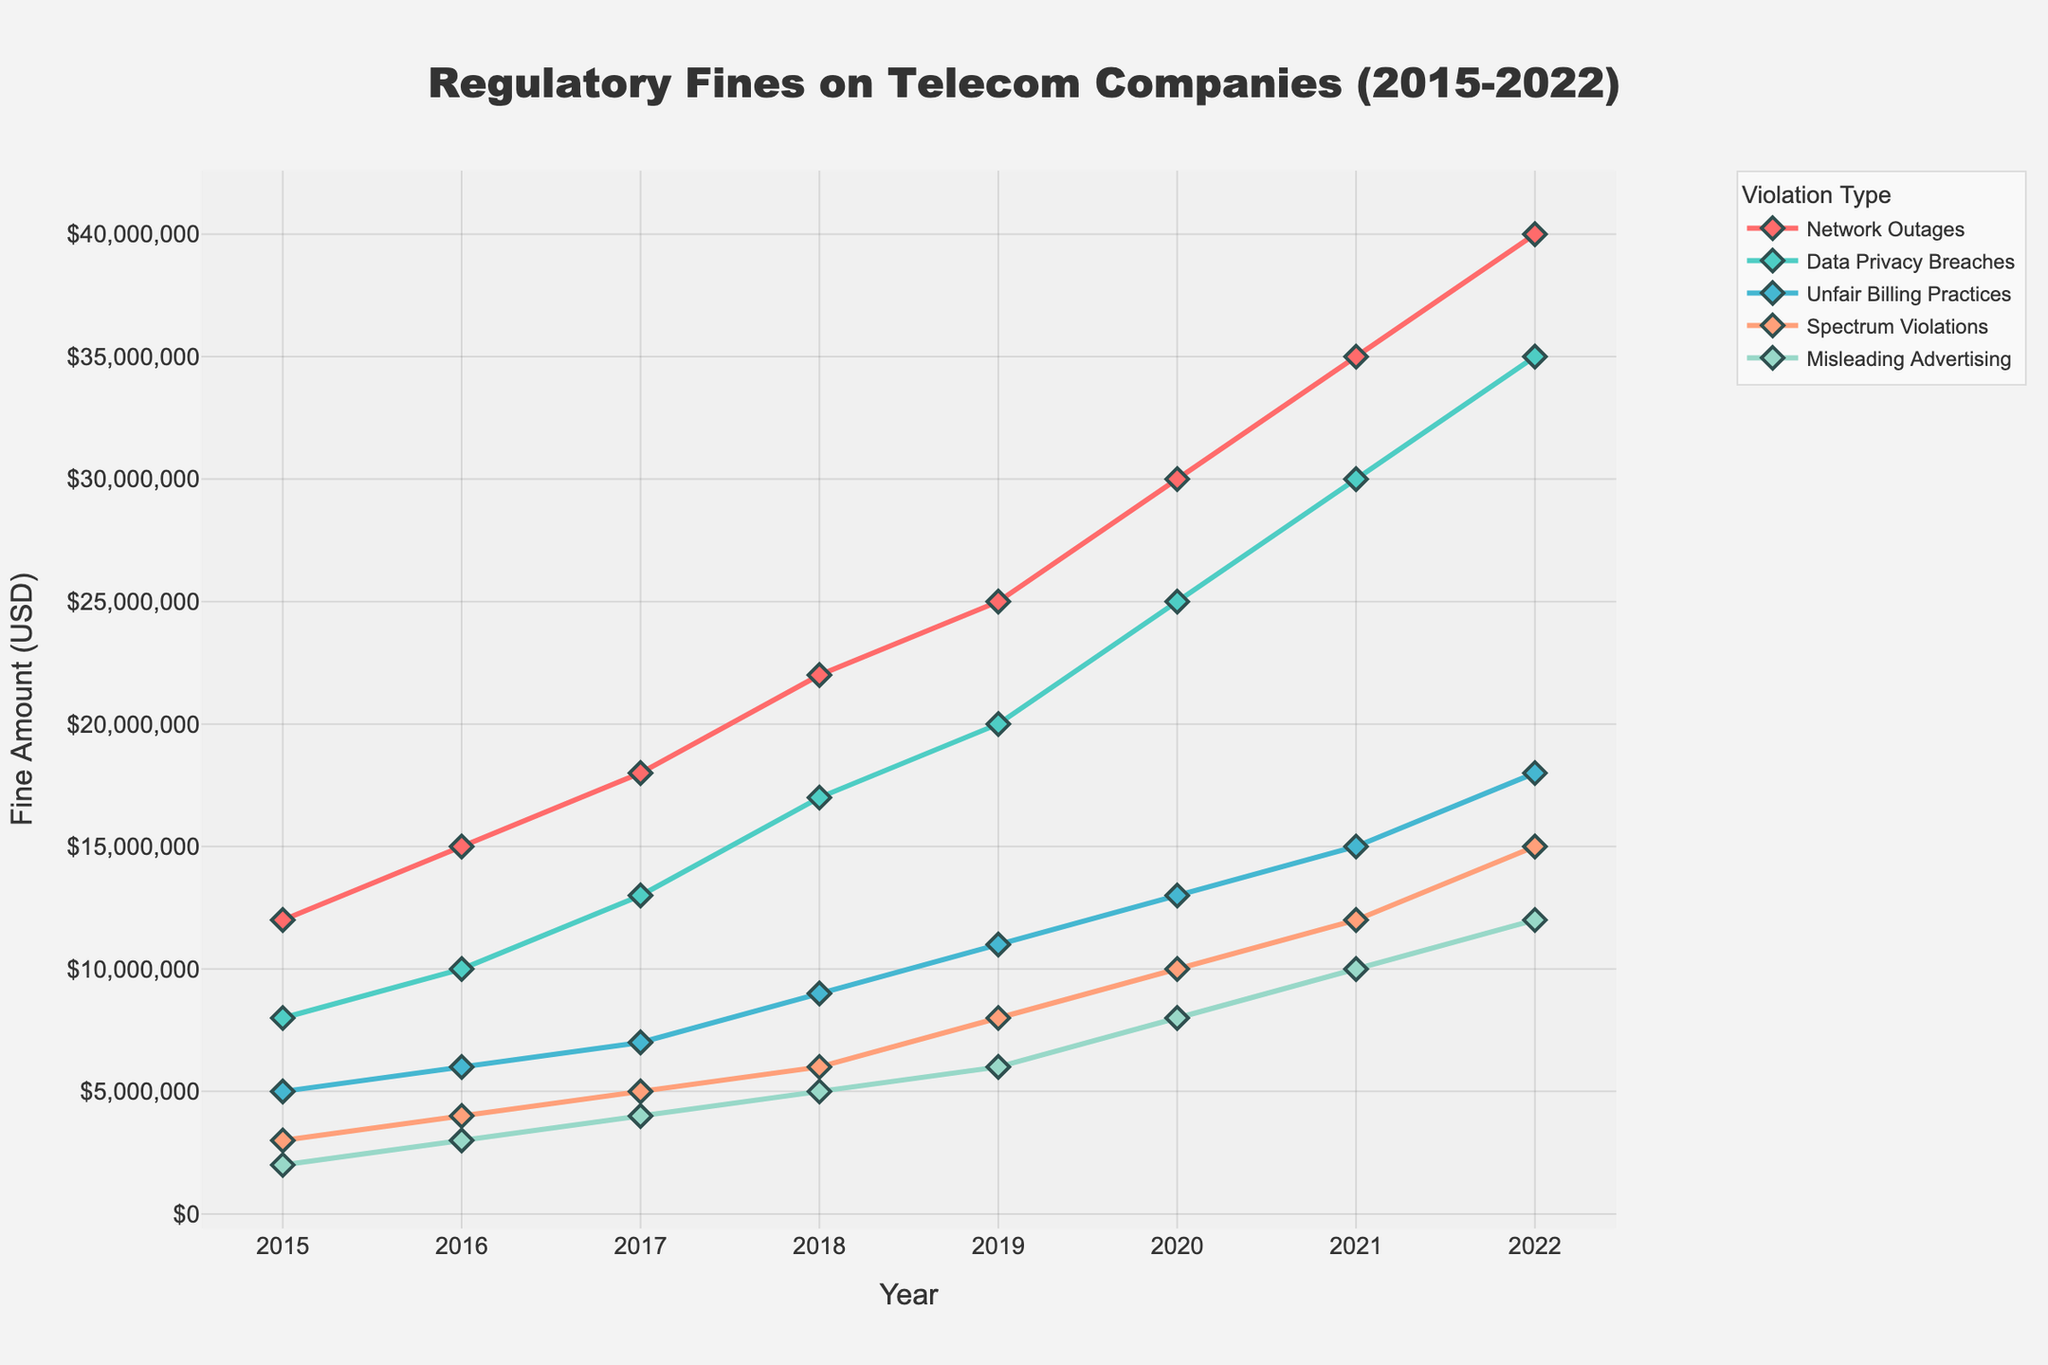What year had the highest fines for Network Outages and how much was it? Look for the peak line in the Network Outages trend and check the corresponding year on the x-axis. The highest point in Network Outages is in 2022.
Answer: 2022, $40,000,000 By how much did fines for Data Privacy Breaches increase from 2018 to 2022? Find the Data Privacy Breaches value in 2018 and 2022, then compute the difference. The values are $17,000,000 in 2018 and $35,000,000 in 2022. The increase is $35,000,000 - $17,000,000 = $18,000,000.
Answer: $18,000,000 Which violation type saw the largest increase in fines from 2015 to 2022? Compare the fines for each violation type in 2015 and 2022, then find the difference and identify the largest. Network Outages increased from $12,000,000 in 2015 to $40,000,000 in 2022, the highest increase ($40,000,000 - $12,000,000 = $28,000,000).
Answer: Network Outages What is the overall trend for fines due to Spectrum Violations from 2015 to 2022? Observe the line corresponding to Spectrum Violations from 2015 to 2022. It shows a consistent upward trend from $3,000,000 in 2015 to $15,000,000 in 2022.
Answer: Increasing Which year had the smallest fine for Misleading Advertising? Look for the lowest point in the Misleading Advertising line and check the corresponding year on the x-axis. The lowest value is in 2015 with $2,000,000.
Answer: 2015 How much more were the total fines for Network Outages and Data Privacy Breaches combined in 2022 compared to 2015? Calculate the sum of fines for Network Outages and Data Privacy Breaches for both years, then find the difference. For 2022: $40,000,000 + $35,000,000 = $75,000,000. For 2015: $12,000,000 + $8,000,000 = $20,000,000. Difference: $75,000,000 - $20,000,000 = $55,000,000.
Answer: $55,000,000 Which violation type's fines remained below $10,000,000 until 2017? Evaluate the fines for each violation type up to 2017, identifying which ones stayed below $10,000,000. Only Spectrum Violations remained below $10,000,000 per year until 2017.
Answer: Spectrum Violations How did the fines for Unfair Billing Practices change from 2016 to 2020? Observe the Unfair Billing Practices line from 2016 to 2020. In 2016, the fine was $6,000,000 and it increased to $13,000,000 by 2020.
Answer: Increased What was the total fine amount for all violation types in 2019? Sum the fines for all violation types in 2019. $25,000,000 (Network Outages) + $20,000,000 (Data Privacy Breaches) + $11,000,000 (Unfair Billing Practices) + $8,000,000 (Spectrum Violations) + $6,000,000 (Misleading Advertising) = $70,000,000.
Answer: $70,000,000 